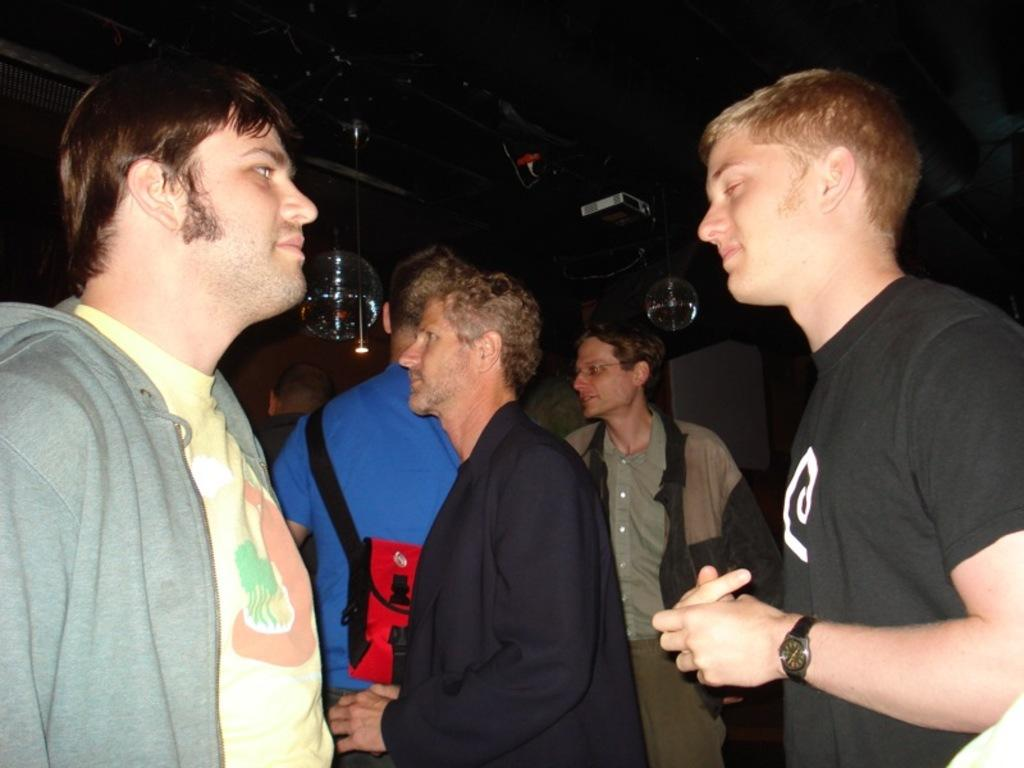What is happening in the image? There are persons standing in the image. Can you describe the background of the image? There are objects in the background of the image. What news is being reported by the man in the image? There is no man or news being reported in the image; it only shows persons standing. 